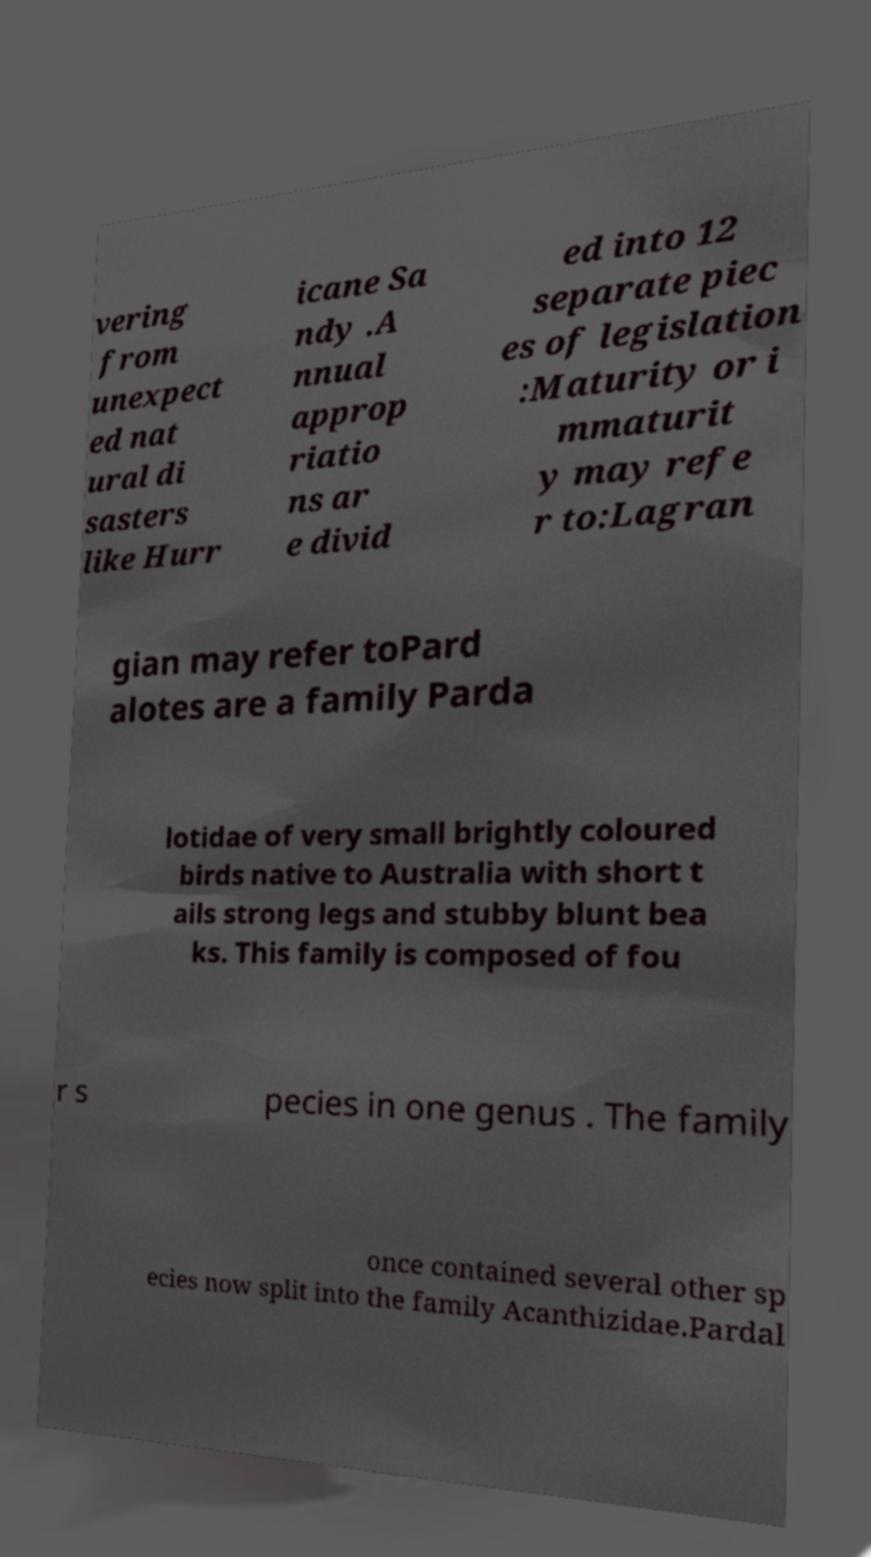Please read and relay the text visible in this image. What does it say? vering from unexpect ed nat ural di sasters like Hurr icane Sa ndy .A nnual approp riatio ns ar e divid ed into 12 separate piec es of legislation :Maturity or i mmaturit y may refe r to:Lagran gian may refer toPard alotes are a family Parda lotidae of very small brightly coloured birds native to Australia with short t ails strong legs and stubby blunt bea ks. This family is composed of fou r s pecies in one genus . The family once contained several other sp ecies now split into the family Acanthizidae.Pardal 